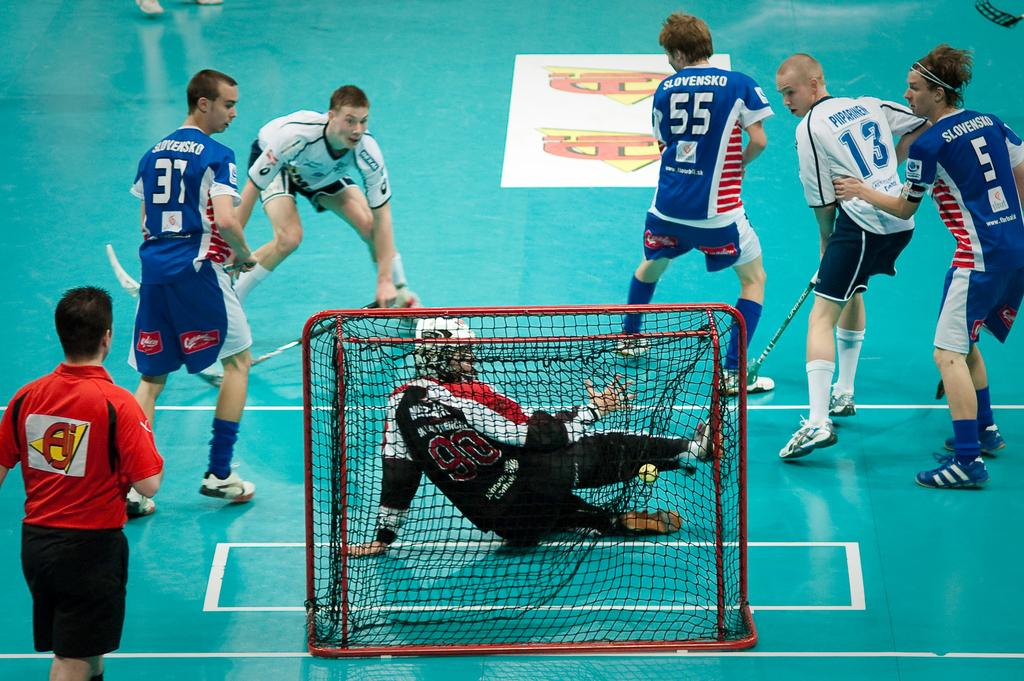What is happening in the image involving a group of boys? The boys are playing hockey in the image. What can be seen in the background related to the game? There is a net in the background of the image. What type of tin is being used by the boys to make decisions during the game? There is no tin present in the image, and the boys are not using any object to make decisions during the game. 